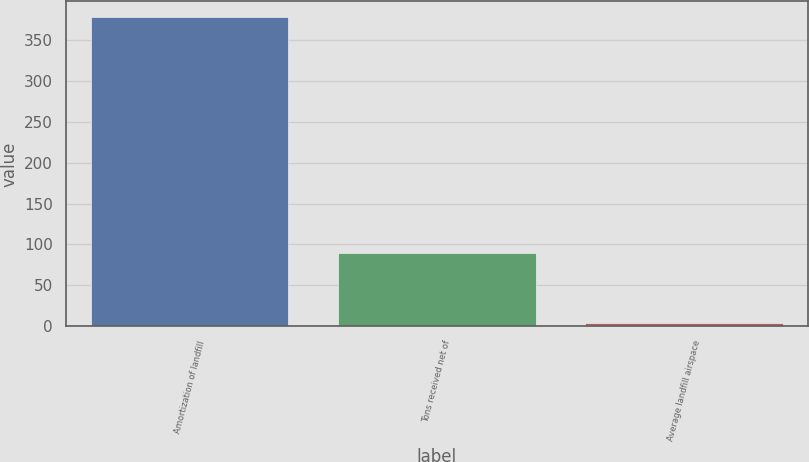Convert chart. <chart><loc_0><loc_0><loc_500><loc_500><bar_chart><fcel>Amortization of landfill<fcel>Tons received net of<fcel>Average landfill airspace<nl><fcel>378<fcel>90<fcel>4.19<nl></chart> 